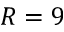Convert formula to latex. <formula><loc_0><loc_0><loc_500><loc_500>R = 9</formula> 